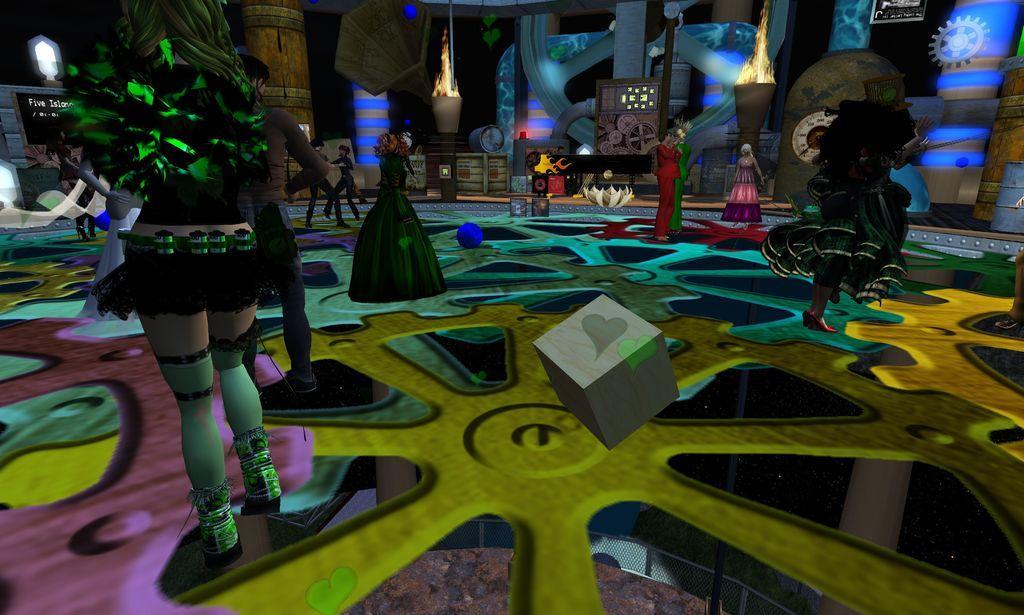In one or two sentences, can you explain what this image depicts? Here this picture looks like an animated picture, as we can see animated floor and we can see animated people dancing on the floor and we can also see lights and all other things that are animated present. 